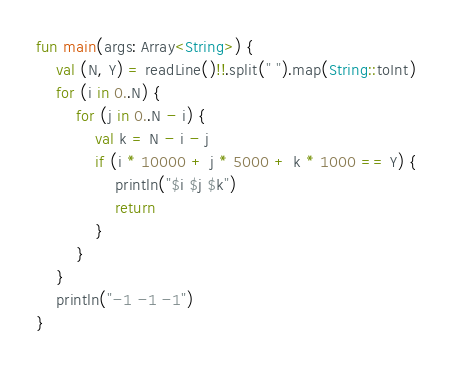Convert code to text. <code><loc_0><loc_0><loc_500><loc_500><_Kotlin_>fun main(args: Array<String>) {
    val (N, Y) = readLine()!!.split(" ").map(String::toInt)
    for (i in 0..N) {
        for (j in 0..N - i) {
            val k = N - i - j
            if (i * 10000 + j * 5000 + k * 1000 == Y) {
                println("$i $j $k")
                return
            }
        }
    }
    println("-1 -1 -1")
}</code> 